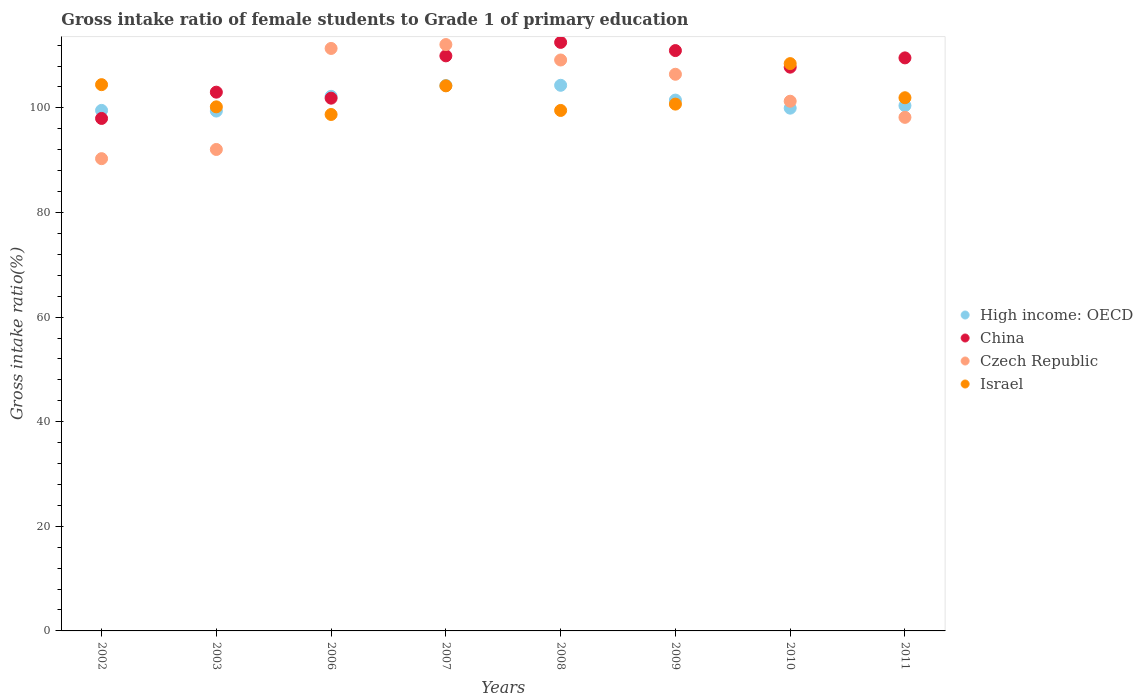Is the number of dotlines equal to the number of legend labels?
Keep it short and to the point. Yes. What is the gross intake ratio in Israel in 2003?
Your response must be concise. 100.2. Across all years, what is the maximum gross intake ratio in High income: OECD?
Your answer should be very brief. 104.32. Across all years, what is the minimum gross intake ratio in Israel?
Your answer should be compact. 98.74. In which year was the gross intake ratio in Israel maximum?
Keep it short and to the point. 2010. In which year was the gross intake ratio in China minimum?
Keep it short and to the point. 2002. What is the total gross intake ratio in China in the graph?
Your answer should be very brief. 853.61. What is the difference between the gross intake ratio in Czech Republic in 2007 and that in 2008?
Offer a terse response. 2.95. What is the difference between the gross intake ratio in High income: OECD in 2007 and the gross intake ratio in Czech Republic in 2009?
Your answer should be very brief. -2.16. What is the average gross intake ratio in High income: OECD per year?
Your answer should be compact. 101.45. In the year 2009, what is the difference between the gross intake ratio in China and gross intake ratio in High income: OECD?
Your answer should be compact. 9.47. In how many years, is the gross intake ratio in High income: OECD greater than 8 %?
Give a very brief answer. 8. What is the ratio of the gross intake ratio in Czech Republic in 2003 to that in 2007?
Your answer should be very brief. 0.82. Is the gross intake ratio in Israel in 2007 less than that in 2010?
Your response must be concise. Yes. What is the difference between the highest and the second highest gross intake ratio in China?
Your answer should be compact. 1.57. What is the difference between the highest and the lowest gross intake ratio in Israel?
Offer a very short reply. 9.73. Is the sum of the gross intake ratio in Israel in 2002 and 2006 greater than the maximum gross intake ratio in Czech Republic across all years?
Provide a succinct answer. Yes. Is it the case that in every year, the sum of the gross intake ratio in China and gross intake ratio in High income: OECD  is greater than the sum of gross intake ratio in Israel and gross intake ratio in Czech Republic?
Provide a succinct answer. No. Is the gross intake ratio in China strictly greater than the gross intake ratio in Israel over the years?
Offer a terse response. No. How many dotlines are there?
Offer a very short reply. 4. What is the difference between two consecutive major ticks on the Y-axis?
Give a very brief answer. 20. Where does the legend appear in the graph?
Give a very brief answer. Center right. What is the title of the graph?
Your response must be concise. Gross intake ratio of female students to Grade 1 of primary education. What is the label or title of the Y-axis?
Your response must be concise. Gross intake ratio(%). What is the Gross intake ratio(%) in High income: OECD in 2002?
Ensure brevity in your answer.  99.52. What is the Gross intake ratio(%) in China in 2002?
Ensure brevity in your answer.  97.98. What is the Gross intake ratio(%) in Czech Republic in 2002?
Your response must be concise. 90.29. What is the Gross intake ratio(%) of Israel in 2002?
Provide a short and direct response. 104.44. What is the Gross intake ratio(%) in High income: OECD in 2003?
Provide a short and direct response. 99.39. What is the Gross intake ratio(%) in China in 2003?
Your answer should be compact. 103. What is the Gross intake ratio(%) in Czech Republic in 2003?
Give a very brief answer. 92.05. What is the Gross intake ratio(%) of Israel in 2003?
Provide a succinct answer. 100.2. What is the Gross intake ratio(%) of High income: OECD in 2006?
Your answer should be compact. 102.21. What is the Gross intake ratio(%) in China in 2006?
Offer a terse response. 101.86. What is the Gross intake ratio(%) in Czech Republic in 2006?
Offer a terse response. 111.36. What is the Gross intake ratio(%) in Israel in 2006?
Make the answer very short. 98.74. What is the Gross intake ratio(%) in High income: OECD in 2007?
Ensure brevity in your answer.  104.27. What is the Gross intake ratio(%) of China in 2007?
Provide a short and direct response. 109.94. What is the Gross intake ratio(%) of Czech Republic in 2007?
Your answer should be very brief. 112.11. What is the Gross intake ratio(%) in Israel in 2007?
Keep it short and to the point. 104.22. What is the Gross intake ratio(%) in High income: OECD in 2008?
Provide a succinct answer. 104.32. What is the Gross intake ratio(%) in China in 2008?
Your answer should be compact. 112.52. What is the Gross intake ratio(%) of Czech Republic in 2008?
Offer a very short reply. 109.16. What is the Gross intake ratio(%) in Israel in 2008?
Your answer should be very brief. 99.51. What is the Gross intake ratio(%) of High income: OECD in 2009?
Make the answer very short. 101.49. What is the Gross intake ratio(%) of China in 2009?
Provide a succinct answer. 110.96. What is the Gross intake ratio(%) in Czech Republic in 2009?
Keep it short and to the point. 106.43. What is the Gross intake ratio(%) in Israel in 2009?
Keep it short and to the point. 100.72. What is the Gross intake ratio(%) of High income: OECD in 2010?
Provide a succinct answer. 99.95. What is the Gross intake ratio(%) of China in 2010?
Provide a succinct answer. 107.78. What is the Gross intake ratio(%) of Czech Republic in 2010?
Keep it short and to the point. 101.27. What is the Gross intake ratio(%) in Israel in 2010?
Provide a short and direct response. 108.47. What is the Gross intake ratio(%) in High income: OECD in 2011?
Ensure brevity in your answer.  100.43. What is the Gross intake ratio(%) in China in 2011?
Provide a succinct answer. 109.56. What is the Gross intake ratio(%) in Czech Republic in 2011?
Your answer should be compact. 98.19. What is the Gross intake ratio(%) of Israel in 2011?
Offer a very short reply. 101.94. Across all years, what is the maximum Gross intake ratio(%) of High income: OECD?
Keep it short and to the point. 104.32. Across all years, what is the maximum Gross intake ratio(%) in China?
Provide a short and direct response. 112.52. Across all years, what is the maximum Gross intake ratio(%) of Czech Republic?
Offer a terse response. 112.11. Across all years, what is the maximum Gross intake ratio(%) in Israel?
Provide a short and direct response. 108.47. Across all years, what is the minimum Gross intake ratio(%) of High income: OECD?
Make the answer very short. 99.39. Across all years, what is the minimum Gross intake ratio(%) of China?
Keep it short and to the point. 97.98. Across all years, what is the minimum Gross intake ratio(%) of Czech Republic?
Your response must be concise. 90.29. Across all years, what is the minimum Gross intake ratio(%) in Israel?
Your response must be concise. 98.74. What is the total Gross intake ratio(%) of High income: OECD in the graph?
Your answer should be very brief. 811.58. What is the total Gross intake ratio(%) in China in the graph?
Provide a succinct answer. 853.61. What is the total Gross intake ratio(%) in Czech Republic in the graph?
Your answer should be very brief. 820.86. What is the total Gross intake ratio(%) in Israel in the graph?
Give a very brief answer. 818.23. What is the difference between the Gross intake ratio(%) of High income: OECD in 2002 and that in 2003?
Your answer should be compact. 0.12. What is the difference between the Gross intake ratio(%) of China in 2002 and that in 2003?
Your answer should be compact. -5.02. What is the difference between the Gross intake ratio(%) in Czech Republic in 2002 and that in 2003?
Your response must be concise. -1.76. What is the difference between the Gross intake ratio(%) of Israel in 2002 and that in 2003?
Offer a very short reply. 4.24. What is the difference between the Gross intake ratio(%) of High income: OECD in 2002 and that in 2006?
Provide a succinct answer. -2.69. What is the difference between the Gross intake ratio(%) in China in 2002 and that in 2006?
Offer a very short reply. -3.88. What is the difference between the Gross intake ratio(%) of Czech Republic in 2002 and that in 2006?
Your response must be concise. -21.07. What is the difference between the Gross intake ratio(%) of Israel in 2002 and that in 2006?
Make the answer very short. 5.7. What is the difference between the Gross intake ratio(%) of High income: OECD in 2002 and that in 2007?
Give a very brief answer. -4.75. What is the difference between the Gross intake ratio(%) in China in 2002 and that in 2007?
Your response must be concise. -11.96. What is the difference between the Gross intake ratio(%) of Czech Republic in 2002 and that in 2007?
Provide a succinct answer. -21.82. What is the difference between the Gross intake ratio(%) of Israel in 2002 and that in 2007?
Offer a terse response. 0.22. What is the difference between the Gross intake ratio(%) of High income: OECD in 2002 and that in 2008?
Your answer should be compact. -4.8. What is the difference between the Gross intake ratio(%) in China in 2002 and that in 2008?
Provide a succinct answer. -14.54. What is the difference between the Gross intake ratio(%) in Czech Republic in 2002 and that in 2008?
Offer a very short reply. -18.86. What is the difference between the Gross intake ratio(%) of Israel in 2002 and that in 2008?
Keep it short and to the point. 4.93. What is the difference between the Gross intake ratio(%) in High income: OECD in 2002 and that in 2009?
Give a very brief answer. -1.97. What is the difference between the Gross intake ratio(%) of China in 2002 and that in 2009?
Ensure brevity in your answer.  -12.98. What is the difference between the Gross intake ratio(%) of Czech Republic in 2002 and that in 2009?
Provide a short and direct response. -16.14. What is the difference between the Gross intake ratio(%) in Israel in 2002 and that in 2009?
Keep it short and to the point. 3.72. What is the difference between the Gross intake ratio(%) in High income: OECD in 2002 and that in 2010?
Your response must be concise. -0.43. What is the difference between the Gross intake ratio(%) in China in 2002 and that in 2010?
Ensure brevity in your answer.  -9.8. What is the difference between the Gross intake ratio(%) of Czech Republic in 2002 and that in 2010?
Offer a terse response. -10.98. What is the difference between the Gross intake ratio(%) of Israel in 2002 and that in 2010?
Provide a short and direct response. -4.02. What is the difference between the Gross intake ratio(%) in High income: OECD in 2002 and that in 2011?
Your answer should be compact. -0.91. What is the difference between the Gross intake ratio(%) in China in 2002 and that in 2011?
Make the answer very short. -11.58. What is the difference between the Gross intake ratio(%) in Czech Republic in 2002 and that in 2011?
Ensure brevity in your answer.  -7.9. What is the difference between the Gross intake ratio(%) of Israel in 2002 and that in 2011?
Provide a succinct answer. 2.5. What is the difference between the Gross intake ratio(%) of High income: OECD in 2003 and that in 2006?
Your response must be concise. -2.81. What is the difference between the Gross intake ratio(%) of China in 2003 and that in 2006?
Provide a succinct answer. 1.15. What is the difference between the Gross intake ratio(%) of Czech Republic in 2003 and that in 2006?
Make the answer very short. -19.31. What is the difference between the Gross intake ratio(%) of Israel in 2003 and that in 2006?
Make the answer very short. 1.46. What is the difference between the Gross intake ratio(%) in High income: OECD in 2003 and that in 2007?
Ensure brevity in your answer.  -4.88. What is the difference between the Gross intake ratio(%) of China in 2003 and that in 2007?
Your answer should be very brief. -6.94. What is the difference between the Gross intake ratio(%) of Czech Republic in 2003 and that in 2007?
Provide a short and direct response. -20.06. What is the difference between the Gross intake ratio(%) in Israel in 2003 and that in 2007?
Your answer should be very brief. -4.02. What is the difference between the Gross intake ratio(%) of High income: OECD in 2003 and that in 2008?
Make the answer very short. -4.93. What is the difference between the Gross intake ratio(%) in China in 2003 and that in 2008?
Ensure brevity in your answer.  -9.52. What is the difference between the Gross intake ratio(%) in Czech Republic in 2003 and that in 2008?
Offer a terse response. -17.11. What is the difference between the Gross intake ratio(%) of Israel in 2003 and that in 2008?
Ensure brevity in your answer.  0.69. What is the difference between the Gross intake ratio(%) of High income: OECD in 2003 and that in 2009?
Offer a very short reply. -2.1. What is the difference between the Gross intake ratio(%) in China in 2003 and that in 2009?
Offer a very short reply. -7.95. What is the difference between the Gross intake ratio(%) in Czech Republic in 2003 and that in 2009?
Provide a short and direct response. -14.38. What is the difference between the Gross intake ratio(%) in Israel in 2003 and that in 2009?
Provide a short and direct response. -0.52. What is the difference between the Gross intake ratio(%) of High income: OECD in 2003 and that in 2010?
Give a very brief answer. -0.55. What is the difference between the Gross intake ratio(%) of China in 2003 and that in 2010?
Ensure brevity in your answer.  -4.78. What is the difference between the Gross intake ratio(%) in Czech Republic in 2003 and that in 2010?
Offer a terse response. -9.22. What is the difference between the Gross intake ratio(%) in Israel in 2003 and that in 2010?
Give a very brief answer. -8.27. What is the difference between the Gross intake ratio(%) in High income: OECD in 2003 and that in 2011?
Keep it short and to the point. -1.04. What is the difference between the Gross intake ratio(%) of China in 2003 and that in 2011?
Your answer should be compact. -6.55. What is the difference between the Gross intake ratio(%) in Czech Republic in 2003 and that in 2011?
Offer a very short reply. -6.14. What is the difference between the Gross intake ratio(%) in Israel in 2003 and that in 2011?
Provide a short and direct response. -1.74. What is the difference between the Gross intake ratio(%) in High income: OECD in 2006 and that in 2007?
Provide a short and direct response. -2.07. What is the difference between the Gross intake ratio(%) in China in 2006 and that in 2007?
Provide a succinct answer. -8.09. What is the difference between the Gross intake ratio(%) in Czech Republic in 2006 and that in 2007?
Offer a very short reply. -0.74. What is the difference between the Gross intake ratio(%) in Israel in 2006 and that in 2007?
Offer a very short reply. -5.48. What is the difference between the Gross intake ratio(%) of High income: OECD in 2006 and that in 2008?
Ensure brevity in your answer.  -2.11. What is the difference between the Gross intake ratio(%) of China in 2006 and that in 2008?
Offer a very short reply. -10.67. What is the difference between the Gross intake ratio(%) in Czech Republic in 2006 and that in 2008?
Provide a succinct answer. 2.21. What is the difference between the Gross intake ratio(%) of Israel in 2006 and that in 2008?
Provide a succinct answer. -0.77. What is the difference between the Gross intake ratio(%) of High income: OECD in 2006 and that in 2009?
Give a very brief answer. 0.72. What is the difference between the Gross intake ratio(%) of China in 2006 and that in 2009?
Ensure brevity in your answer.  -9.1. What is the difference between the Gross intake ratio(%) of Czech Republic in 2006 and that in 2009?
Your answer should be compact. 4.94. What is the difference between the Gross intake ratio(%) in Israel in 2006 and that in 2009?
Provide a succinct answer. -1.98. What is the difference between the Gross intake ratio(%) in High income: OECD in 2006 and that in 2010?
Your response must be concise. 2.26. What is the difference between the Gross intake ratio(%) in China in 2006 and that in 2010?
Your answer should be very brief. -5.93. What is the difference between the Gross intake ratio(%) of Czech Republic in 2006 and that in 2010?
Give a very brief answer. 10.09. What is the difference between the Gross intake ratio(%) of Israel in 2006 and that in 2010?
Provide a succinct answer. -9.73. What is the difference between the Gross intake ratio(%) in High income: OECD in 2006 and that in 2011?
Your answer should be compact. 1.78. What is the difference between the Gross intake ratio(%) of China in 2006 and that in 2011?
Offer a terse response. -7.7. What is the difference between the Gross intake ratio(%) in Czech Republic in 2006 and that in 2011?
Give a very brief answer. 13.17. What is the difference between the Gross intake ratio(%) of Israel in 2006 and that in 2011?
Make the answer very short. -3.2. What is the difference between the Gross intake ratio(%) of High income: OECD in 2007 and that in 2008?
Your answer should be compact. -0.05. What is the difference between the Gross intake ratio(%) in China in 2007 and that in 2008?
Make the answer very short. -2.58. What is the difference between the Gross intake ratio(%) of Czech Republic in 2007 and that in 2008?
Provide a succinct answer. 2.95. What is the difference between the Gross intake ratio(%) of Israel in 2007 and that in 2008?
Offer a very short reply. 4.7. What is the difference between the Gross intake ratio(%) of High income: OECD in 2007 and that in 2009?
Your answer should be compact. 2.78. What is the difference between the Gross intake ratio(%) of China in 2007 and that in 2009?
Offer a terse response. -1.01. What is the difference between the Gross intake ratio(%) of Czech Republic in 2007 and that in 2009?
Offer a very short reply. 5.68. What is the difference between the Gross intake ratio(%) in Israel in 2007 and that in 2009?
Your response must be concise. 3.49. What is the difference between the Gross intake ratio(%) in High income: OECD in 2007 and that in 2010?
Your answer should be compact. 4.32. What is the difference between the Gross intake ratio(%) in China in 2007 and that in 2010?
Provide a short and direct response. 2.16. What is the difference between the Gross intake ratio(%) in Czech Republic in 2007 and that in 2010?
Your answer should be very brief. 10.83. What is the difference between the Gross intake ratio(%) of Israel in 2007 and that in 2010?
Keep it short and to the point. -4.25. What is the difference between the Gross intake ratio(%) in High income: OECD in 2007 and that in 2011?
Your answer should be very brief. 3.84. What is the difference between the Gross intake ratio(%) in China in 2007 and that in 2011?
Offer a terse response. 0.39. What is the difference between the Gross intake ratio(%) in Czech Republic in 2007 and that in 2011?
Make the answer very short. 13.92. What is the difference between the Gross intake ratio(%) of Israel in 2007 and that in 2011?
Keep it short and to the point. 2.28. What is the difference between the Gross intake ratio(%) of High income: OECD in 2008 and that in 2009?
Give a very brief answer. 2.83. What is the difference between the Gross intake ratio(%) of China in 2008 and that in 2009?
Offer a very short reply. 1.57. What is the difference between the Gross intake ratio(%) of Czech Republic in 2008 and that in 2009?
Offer a terse response. 2.73. What is the difference between the Gross intake ratio(%) in Israel in 2008 and that in 2009?
Provide a short and direct response. -1.21. What is the difference between the Gross intake ratio(%) of High income: OECD in 2008 and that in 2010?
Ensure brevity in your answer.  4.37. What is the difference between the Gross intake ratio(%) in China in 2008 and that in 2010?
Give a very brief answer. 4.74. What is the difference between the Gross intake ratio(%) of Czech Republic in 2008 and that in 2010?
Your response must be concise. 7.88. What is the difference between the Gross intake ratio(%) in Israel in 2008 and that in 2010?
Provide a succinct answer. -8.95. What is the difference between the Gross intake ratio(%) of High income: OECD in 2008 and that in 2011?
Give a very brief answer. 3.89. What is the difference between the Gross intake ratio(%) of China in 2008 and that in 2011?
Offer a terse response. 2.96. What is the difference between the Gross intake ratio(%) of Czech Republic in 2008 and that in 2011?
Your answer should be very brief. 10.97. What is the difference between the Gross intake ratio(%) in Israel in 2008 and that in 2011?
Your response must be concise. -2.43. What is the difference between the Gross intake ratio(%) in High income: OECD in 2009 and that in 2010?
Your answer should be very brief. 1.54. What is the difference between the Gross intake ratio(%) in China in 2009 and that in 2010?
Keep it short and to the point. 3.17. What is the difference between the Gross intake ratio(%) of Czech Republic in 2009 and that in 2010?
Your answer should be compact. 5.15. What is the difference between the Gross intake ratio(%) of Israel in 2009 and that in 2010?
Ensure brevity in your answer.  -7.74. What is the difference between the Gross intake ratio(%) in High income: OECD in 2009 and that in 2011?
Your response must be concise. 1.06. What is the difference between the Gross intake ratio(%) in China in 2009 and that in 2011?
Your response must be concise. 1.4. What is the difference between the Gross intake ratio(%) in Czech Republic in 2009 and that in 2011?
Offer a very short reply. 8.24. What is the difference between the Gross intake ratio(%) in Israel in 2009 and that in 2011?
Make the answer very short. -1.22. What is the difference between the Gross intake ratio(%) in High income: OECD in 2010 and that in 2011?
Your answer should be compact. -0.48. What is the difference between the Gross intake ratio(%) of China in 2010 and that in 2011?
Ensure brevity in your answer.  -1.77. What is the difference between the Gross intake ratio(%) of Czech Republic in 2010 and that in 2011?
Give a very brief answer. 3.08. What is the difference between the Gross intake ratio(%) in Israel in 2010 and that in 2011?
Provide a succinct answer. 6.53. What is the difference between the Gross intake ratio(%) in High income: OECD in 2002 and the Gross intake ratio(%) in China in 2003?
Give a very brief answer. -3.49. What is the difference between the Gross intake ratio(%) of High income: OECD in 2002 and the Gross intake ratio(%) of Czech Republic in 2003?
Ensure brevity in your answer.  7.47. What is the difference between the Gross intake ratio(%) in High income: OECD in 2002 and the Gross intake ratio(%) in Israel in 2003?
Offer a very short reply. -0.68. What is the difference between the Gross intake ratio(%) in China in 2002 and the Gross intake ratio(%) in Czech Republic in 2003?
Keep it short and to the point. 5.93. What is the difference between the Gross intake ratio(%) in China in 2002 and the Gross intake ratio(%) in Israel in 2003?
Give a very brief answer. -2.22. What is the difference between the Gross intake ratio(%) in Czech Republic in 2002 and the Gross intake ratio(%) in Israel in 2003?
Offer a terse response. -9.91. What is the difference between the Gross intake ratio(%) in High income: OECD in 2002 and the Gross intake ratio(%) in China in 2006?
Provide a short and direct response. -2.34. What is the difference between the Gross intake ratio(%) in High income: OECD in 2002 and the Gross intake ratio(%) in Czech Republic in 2006?
Give a very brief answer. -11.85. What is the difference between the Gross intake ratio(%) in High income: OECD in 2002 and the Gross intake ratio(%) in Israel in 2006?
Make the answer very short. 0.78. What is the difference between the Gross intake ratio(%) of China in 2002 and the Gross intake ratio(%) of Czech Republic in 2006?
Provide a short and direct response. -13.38. What is the difference between the Gross intake ratio(%) of China in 2002 and the Gross intake ratio(%) of Israel in 2006?
Offer a very short reply. -0.76. What is the difference between the Gross intake ratio(%) of Czech Republic in 2002 and the Gross intake ratio(%) of Israel in 2006?
Provide a succinct answer. -8.45. What is the difference between the Gross intake ratio(%) of High income: OECD in 2002 and the Gross intake ratio(%) of China in 2007?
Make the answer very short. -10.43. What is the difference between the Gross intake ratio(%) in High income: OECD in 2002 and the Gross intake ratio(%) in Czech Republic in 2007?
Keep it short and to the point. -12.59. What is the difference between the Gross intake ratio(%) in High income: OECD in 2002 and the Gross intake ratio(%) in Israel in 2007?
Your answer should be compact. -4.7. What is the difference between the Gross intake ratio(%) in China in 2002 and the Gross intake ratio(%) in Czech Republic in 2007?
Give a very brief answer. -14.13. What is the difference between the Gross intake ratio(%) in China in 2002 and the Gross intake ratio(%) in Israel in 2007?
Ensure brevity in your answer.  -6.24. What is the difference between the Gross intake ratio(%) of Czech Republic in 2002 and the Gross intake ratio(%) of Israel in 2007?
Keep it short and to the point. -13.92. What is the difference between the Gross intake ratio(%) in High income: OECD in 2002 and the Gross intake ratio(%) in China in 2008?
Offer a very short reply. -13. What is the difference between the Gross intake ratio(%) in High income: OECD in 2002 and the Gross intake ratio(%) in Czech Republic in 2008?
Your answer should be very brief. -9.64. What is the difference between the Gross intake ratio(%) of High income: OECD in 2002 and the Gross intake ratio(%) of Israel in 2008?
Offer a very short reply. 0.01. What is the difference between the Gross intake ratio(%) in China in 2002 and the Gross intake ratio(%) in Czech Republic in 2008?
Ensure brevity in your answer.  -11.18. What is the difference between the Gross intake ratio(%) in China in 2002 and the Gross intake ratio(%) in Israel in 2008?
Your answer should be very brief. -1.53. What is the difference between the Gross intake ratio(%) of Czech Republic in 2002 and the Gross intake ratio(%) of Israel in 2008?
Offer a terse response. -9.22. What is the difference between the Gross intake ratio(%) in High income: OECD in 2002 and the Gross intake ratio(%) in China in 2009?
Your response must be concise. -11.44. What is the difference between the Gross intake ratio(%) of High income: OECD in 2002 and the Gross intake ratio(%) of Czech Republic in 2009?
Offer a very short reply. -6.91. What is the difference between the Gross intake ratio(%) in High income: OECD in 2002 and the Gross intake ratio(%) in Israel in 2009?
Give a very brief answer. -1.2. What is the difference between the Gross intake ratio(%) in China in 2002 and the Gross intake ratio(%) in Czech Republic in 2009?
Your response must be concise. -8.45. What is the difference between the Gross intake ratio(%) of China in 2002 and the Gross intake ratio(%) of Israel in 2009?
Your answer should be compact. -2.74. What is the difference between the Gross intake ratio(%) of Czech Republic in 2002 and the Gross intake ratio(%) of Israel in 2009?
Provide a short and direct response. -10.43. What is the difference between the Gross intake ratio(%) in High income: OECD in 2002 and the Gross intake ratio(%) in China in 2010?
Your response must be concise. -8.27. What is the difference between the Gross intake ratio(%) in High income: OECD in 2002 and the Gross intake ratio(%) in Czech Republic in 2010?
Provide a succinct answer. -1.75. What is the difference between the Gross intake ratio(%) of High income: OECD in 2002 and the Gross intake ratio(%) of Israel in 2010?
Your response must be concise. -8.95. What is the difference between the Gross intake ratio(%) in China in 2002 and the Gross intake ratio(%) in Czech Republic in 2010?
Offer a very short reply. -3.29. What is the difference between the Gross intake ratio(%) of China in 2002 and the Gross intake ratio(%) of Israel in 2010?
Keep it short and to the point. -10.48. What is the difference between the Gross intake ratio(%) of Czech Republic in 2002 and the Gross intake ratio(%) of Israel in 2010?
Your response must be concise. -18.17. What is the difference between the Gross intake ratio(%) in High income: OECD in 2002 and the Gross intake ratio(%) in China in 2011?
Offer a very short reply. -10.04. What is the difference between the Gross intake ratio(%) of High income: OECD in 2002 and the Gross intake ratio(%) of Czech Republic in 2011?
Provide a short and direct response. 1.33. What is the difference between the Gross intake ratio(%) in High income: OECD in 2002 and the Gross intake ratio(%) in Israel in 2011?
Your response must be concise. -2.42. What is the difference between the Gross intake ratio(%) in China in 2002 and the Gross intake ratio(%) in Czech Republic in 2011?
Provide a succinct answer. -0.21. What is the difference between the Gross intake ratio(%) of China in 2002 and the Gross intake ratio(%) of Israel in 2011?
Your answer should be compact. -3.96. What is the difference between the Gross intake ratio(%) of Czech Republic in 2002 and the Gross intake ratio(%) of Israel in 2011?
Your response must be concise. -11.65. What is the difference between the Gross intake ratio(%) in High income: OECD in 2003 and the Gross intake ratio(%) in China in 2006?
Provide a succinct answer. -2.46. What is the difference between the Gross intake ratio(%) of High income: OECD in 2003 and the Gross intake ratio(%) of Czech Republic in 2006?
Ensure brevity in your answer.  -11.97. What is the difference between the Gross intake ratio(%) in High income: OECD in 2003 and the Gross intake ratio(%) in Israel in 2006?
Provide a short and direct response. 0.66. What is the difference between the Gross intake ratio(%) in China in 2003 and the Gross intake ratio(%) in Czech Republic in 2006?
Your answer should be compact. -8.36. What is the difference between the Gross intake ratio(%) of China in 2003 and the Gross intake ratio(%) of Israel in 2006?
Your response must be concise. 4.27. What is the difference between the Gross intake ratio(%) of Czech Republic in 2003 and the Gross intake ratio(%) of Israel in 2006?
Provide a succinct answer. -6.69. What is the difference between the Gross intake ratio(%) of High income: OECD in 2003 and the Gross intake ratio(%) of China in 2007?
Offer a terse response. -10.55. What is the difference between the Gross intake ratio(%) of High income: OECD in 2003 and the Gross intake ratio(%) of Czech Republic in 2007?
Provide a short and direct response. -12.71. What is the difference between the Gross intake ratio(%) in High income: OECD in 2003 and the Gross intake ratio(%) in Israel in 2007?
Offer a very short reply. -4.82. What is the difference between the Gross intake ratio(%) in China in 2003 and the Gross intake ratio(%) in Czech Republic in 2007?
Make the answer very short. -9.1. What is the difference between the Gross intake ratio(%) in China in 2003 and the Gross intake ratio(%) in Israel in 2007?
Give a very brief answer. -1.21. What is the difference between the Gross intake ratio(%) in Czech Republic in 2003 and the Gross intake ratio(%) in Israel in 2007?
Provide a short and direct response. -12.17. What is the difference between the Gross intake ratio(%) of High income: OECD in 2003 and the Gross intake ratio(%) of China in 2008?
Keep it short and to the point. -13.13. What is the difference between the Gross intake ratio(%) of High income: OECD in 2003 and the Gross intake ratio(%) of Czech Republic in 2008?
Give a very brief answer. -9.76. What is the difference between the Gross intake ratio(%) in High income: OECD in 2003 and the Gross intake ratio(%) in Israel in 2008?
Provide a succinct answer. -0.12. What is the difference between the Gross intake ratio(%) of China in 2003 and the Gross intake ratio(%) of Czech Republic in 2008?
Make the answer very short. -6.15. What is the difference between the Gross intake ratio(%) of China in 2003 and the Gross intake ratio(%) of Israel in 2008?
Provide a succinct answer. 3.49. What is the difference between the Gross intake ratio(%) of Czech Republic in 2003 and the Gross intake ratio(%) of Israel in 2008?
Keep it short and to the point. -7.46. What is the difference between the Gross intake ratio(%) in High income: OECD in 2003 and the Gross intake ratio(%) in China in 2009?
Offer a terse response. -11.56. What is the difference between the Gross intake ratio(%) of High income: OECD in 2003 and the Gross intake ratio(%) of Czech Republic in 2009?
Your response must be concise. -7.03. What is the difference between the Gross intake ratio(%) in High income: OECD in 2003 and the Gross intake ratio(%) in Israel in 2009?
Provide a short and direct response. -1.33. What is the difference between the Gross intake ratio(%) in China in 2003 and the Gross intake ratio(%) in Czech Republic in 2009?
Your answer should be compact. -3.42. What is the difference between the Gross intake ratio(%) in China in 2003 and the Gross intake ratio(%) in Israel in 2009?
Offer a terse response. 2.28. What is the difference between the Gross intake ratio(%) in Czech Republic in 2003 and the Gross intake ratio(%) in Israel in 2009?
Offer a terse response. -8.67. What is the difference between the Gross intake ratio(%) of High income: OECD in 2003 and the Gross intake ratio(%) of China in 2010?
Your answer should be very brief. -8.39. What is the difference between the Gross intake ratio(%) of High income: OECD in 2003 and the Gross intake ratio(%) of Czech Republic in 2010?
Make the answer very short. -1.88. What is the difference between the Gross intake ratio(%) in High income: OECD in 2003 and the Gross intake ratio(%) in Israel in 2010?
Offer a terse response. -9.07. What is the difference between the Gross intake ratio(%) of China in 2003 and the Gross intake ratio(%) of Czech Republic in 2010?
Keep it short and to the point. 1.73. What is the difference between the Gross intake ratio(%) in China in 2003 and the Gross intake ratio(%) in Israel in 2010?
Offer a terse response. -5.46. What is the difference between the Gross intake ratio(%) of Czech Republic in 2003 and the Gross intake ratio(%) of Israel in 2010?
Provide a short and direct response. -16.42. What is the difference between the Gross intake ratio(%) in High income: OECD in 2003 and the Gross intake ratio(%) in China in 2011?
Give a very brief answer. -10.16. What is the difference between the Gross intake ratio(%) of High income: OECD in 2003 and the Gross intake ratio(%) of Czech Republic in 2011?
Your answer should be compact. 1.2. What is the difference between the Gross intake ratio(%) of High income: OECD in 2003 and the Gross intake ratio(%) of Israel in 2011?
Keep it short and to the point. -2.54. What is the difference between the Gross intake ratio(%) of China in 2003 and the Gross intake ratio(%) of Czech Republic in 2011?
Offer a terse response. 4.81. What is the difference between the Gross intake ratio(%) of China in 2003 and the Gross intake ratio(%) of Israel in 2011?
Your response must be concise. 1.07. What is the difference between the Gross intake ratio(%) of Czech Republic in 2003 and the Gross intake ratio(%) of Israel in 2011?
Provide a short and direct response. -9.89. What is the difference between the Gross intake ratio(%) in High income: OECD in 2006 and the Gross intake ratio(%) in China in 2007?
Make the answer very short. -7.74. What is the difference between the Gross intake ratio(%) of High income: OECD in 2006 and the Gross intake ratio(%) of Czech Republic in 2007?
Provide a succinct answer. -9.9. What is the difference between the Gross intake ratio(%) of High income: OECD in 2006 and the Gross intake ratio(%) of Israel in 2007?
Make the answer very short. -2.01. What is the difference between the Gross intake ratio(%) in China in 2006 and the Gross intake ratio(%) in Czech Republic in 2007?
Give a very brief answer. -10.25. What is the difference between the Gross intake ratio(%) of China in 2006 and the Gross intake ratio(%) of Israel in 2007?
Make the answer very short. -2.36. What is the difference between the Gross intake ratio(%) in Czech Republic in 2006 and the Gross intake ratio(%) in Israel in 2007?
Offer a terse response. 7.15. What is the difference between the Gross intake ratio(%) in High income: OECD in 2006 and the Gross intake ratio(%) in China in 2008?
Offer a very short reply. -10.32. What is the difference between the Gross intake ratio(%) in High income: OECD in 2006 and the Gross intake ratio(%) in Czech Republic in 2008?
Offer a terse response. -6.95. What is the difference between the Gross intake ratio(%) in High income: OECD in 2006 and the Gross intake ratio(%) in Israel in 2008?
Offer a terse response. 2.7. What is the difference between the Gross intake ratio(%) in China in 2006 and the Gross intake ratio(%) in Czech Republic in 2008?
Offer a terse response. -7.3. What is the difference between the Gross intake ratio(%) in China in 2006 and the Gross intake ratio(%) in Israel in 2008?
Your answer should be very brief. 2.35. What is the difference between the Gross intake ratio(%) in Czech Republic in 2006 and the Gross intake ratio(%) in Israel in 2008?
Keep it short and to the point. 11.85. What is the difference between the Gross intake ratio(%) of High income: OECD in 2006 and the Gross intake ratio(%) of China in 2009?
Keep it short and to the point. -8.75. What is the difference between the Gross intake ratio(%) in High income: OECD in 2006 and the Gross intake ratio(%) in Czech Republic in 2009?
Give a very brief answer. -4.22. What is the difference between the Gross intake ratio(%) of High income: OECD in 2006 and the Gross intake ratio(%) of Israel in 2009?
Give a very brief answer. 1.49. What is the difference between the Gross intake ratio(%) of China in 2006 and the Gross intake ratio(%) of Czech Republic in 2009?
Give a very brief answer. -4.57. What is the difference between the Gross intake ratio(%) in China in 2006 and the Gross intake ratio(%) in Israel in 2009?
Give a very brief answer. 1.13. What is the difference between the Gross intake ratio(%) in Czech Republic in 2006 and the Gross intake ratio(%) in Israel in 2009?
Offer a very short reply. 10.64. What is the difference between the Gross intake ratio(%) of High income: OECD in 2006 and the Gross intake ratio(%) of China in 2010?
Ensure brevity in your answer.  -5.58. What is the difference between the Gross intake ratio(%) in High income: OECD in 2006 and the Gross intake ratio(%) in Czech Republic in 2010?
Offer a terse response. 0.93. What is the difference between the Gross intake ratio(%) in High income: OECD in 2006 and the Gross intake ratio(%) in Israel in 2010?
Provide a succinct answer. -6.26. What is the difference between the Gross intake ratio(%) of China in 2006 and the Gross intake ratio(%) of Czech Republic in 2010?
Offer a terse response. 0.58. What is the difference between the Gross intake ratio(%) of China in 2006 and the Gross intake ratio(%) of Israel in 2010?
Give a very brief answer. -6.61. What is the difference between the Gross intake ratio(%) in Czech Republic in 2006 and the Gross intake ratio(%) in Israel in 2010?
Ensure brevity in your answer.  2.9. What is the difference between the Gross intake ratio(%) in High income: OECD in 2006 and the Gross intake ratio(%) in China in 2011?
Your answer should be compact. -7.35. What is the difference between the Gross intake ratio(%) of High income: OECD in 2006 and the Gross intake ratio(%) of Czech Republic in 2011?
Ensure brevity in your answer.  4.02. What is the difference between the Gross intake ratio(%) of High income: OECD in 2006 and the Gross intake ratio(%) of Israel in 2011?
Give a very brief answer. 0.27. What is the difference between the Gross intake ratio(%) of China in 2006 and the Gross intake ratio(%) of Czech Republic in 2011?
Make the answer very short. 3.67. What is the difference between the Gross intake ratio(%) in China in 2006 and the Gross intake ratio(%) in Israel in 2011?
Your answer should be compact. -0.08. What is the difference between the Gross intake ratio(%) of Czech Republic in 2006 and the Gross intake ratio(%) of Israel in 2011?
Keep it short and to the point. 9.43. What is the difference between the Gross intake ratio(%) of High income: OECD in 2007 and the Gross intake ratio(%) of China in 2008?
Your response must be concise. -8.25. What is the difference between the Gross intake ratio(%) in High income: OECD in 2007 and the Gross intake ratio(%) in Czech Republic in 2008?
Keep it short and to the point. -4.88. What is the difference between the Gross intake ratio(%) in High income: OECD in 2007 and the Gross intake ratio(%) in Israel in 2008?
Your response must be concise. 4.76. What is the difference between the Gross intake ratio(%) in China in 2007 and the Gross intake ratio(%) in Czech Republic in 2008?
Your response must be concise. 0.79. What is the difference between the Gross intake ratio(%) in China in 2007 and the Gross intake ratio(%) in Israel in 2008?
Offer a very short reply. 10.43. What is the difference between the Gross intake ratio(%) in Czech Republic in 2007 and the Gross intake ratio(%) in Israel in 2008?
Ensure brevity in your answer.  12.6. What is the difference between the Gross intake ratio(%) of High income: OECD in 2007 and the Gross intake ratio(%) of China in 2009?
Provide a succinct answer. -6.68. What is the difference between the Gross intake ratio(%) of High income: OECD in 2007 and the Gross intake ratio(%) of Czech Republic in 2009?
Your answer should be compact. -2.16. What is the difference between the Gross intake ratio(%) of High income: OECD in 2007 and the Gross intake ratio(%) of Israel in 2009?
Ensure brevity in your answer.  3.55. What is the difference between the Gross intake ratio(%) in China in 2007 and the Gross intake ratio(%) in Czech Republic in 2009?
Ensure brevity in your answer.  3.52. What is the difference between the Gross intake ratio(%) in China in 2007 and the Gross intake ratio(%) in Israel in 2009?
Make the answer very short. 9.22. What is the difference between the Gross intake ratio(%) in Czech Republic in 2007 and the Gross intake ratio(%) in Israel in 2009?
Provide a short and direct response. 11.38. What is the difference between the Gross intake ratio(%) of High income: OECD in 2007 and the Gross intake ratio(%) of China in 2010?
Your answer should be compact. -3.51. What is the difference between the Gross intake ratio(%) of High income: OECD in 2007 and the Gross intake ratio(%) of Czech Republic in 2010?
Offer a very short reply. 3. What is the difference between the Gross intake ratio(%) in High income: OECD in 2007 and the Gross intake ratio(%) in Israel in 2010?
Ensure brevity in your answer.  -4.19. What is the difference between the Gross intake ratio(%) of China in 2007 and the Gross intake ratio(%) of Czech Republic in 2010?
Offer a terse response. 8.67. What is the difference between the Gross intake ratio(%) of China in 2007 and the Gross intake ratio(%) of Israel in 2010?
Give a very brief answer. 1.48. What is the difference between the Gross intake ratio(%) of Czech Republic in 2007 and the Gross intake ratio(%) of Israel in 2010?
Keep it short and to the point. 3.64. What is the difference between the Gross intake ratio(%) of High income: OECD in 2007 and the Gross intake ratio(%) of China in 2011?
Your answer should be compact. -5.29. What is the difference between the Gross intake ratio(%) of High income: OECD in 2007 and the Gross intake ratio(%) of Czech Republic in 2011?
Keep it short and to the point. 6.08. What is the difference between the Gross intake ratio(%) of High income: OECD in 2007 and the Gross intake ratio(%) of Israel in 2011?
Offer a very short reply. 2.33. What is the difference between the Gross intake ratio(%) of China in 2007 and the Gross intake ratio(%) of Czech Republic in 2011?
Offer a terse response. 11.75. What is the difference between the Gross intake ratio(%) in China in 2007 and the Gross intake ratio(%) in Israel in 2011?
Keep it short and to the point. 8.01. What is the difference between the Gross intake ratio(%) in Czech Republic in 2007 and the Gross intake ratio(%) in Israel in 2011?
Give a very brief answer. 10.17. What is the difference between the Gross intake ratio(%) in High income: OECD in 2008 and the Gross intake ratio(%) in China in 2009?
Your answer should be compact. -6.64. What is the difference between the Gross intake ratio(%) of High income: OECD in 2008 and the Gross intake ratio(%) of Czech Republic in 2009?
Ensure brevity in your answer.  -2.11. What is the difference between the Gross intake ratio(%) of High income: OECD in 2008 and the Gross intake ratio(%) of Israel in 2009?
Your response must be concise. 3.6. What is the difference between the Gross intake ratio(%) of China in 2008 and the Gross intake ratio(%) of Czech Republic in 2009?
Your answer should be very brief. 6.09. What is the difference between the Gross intake ratio(%) in China in 2008 and the Gross intake ratio(%) in Israel in 2009?
Give a very brief answer. 11.8. What is the difference between the Gross intake ratio(%) in Czech Republic in 2008 and the Gross intake ratio(%) in Israel in 2009?
Provide a short and direct response. 8.43. What is the difference between the Gross intake ratio(%) in High income: OECD in 2008 and the Gross intake ratio(%) in China in 2010?
Provide a succinct answer. -3.46. What is the difference between the Gross intake ratio(%) of High income: OECD in 2008 and the Gross intake ratio(%) of Czech Republic in 2010?
Offer a terse response. 3.05. What is the difference between the Gross intake ratio(%) of High income: OECD in 2008 and the Gross intake ratio(%) of Israel in 2010?
Provide a short and direct response. -4.15. What is the difference between the Gross intake ratio(%) of China in 2008 and the Gross intake ratio(%) of Czech Republic in 2010?
Ensure brevity in your answer.  11.25. What is the difference between the Gross intake ratio(%) of China in 2008 and the Gross intake ratio(%) of Israel in 2010?
Offer a terse response. 4.06. What is the difference between the Gross intake ratio(%) in Czech Republic in 2008 and the Gross intake ratio(%) in Israel in 2010?
Keep it short and to the point. 0.69. What is the difference between the Gross intake ratio(%) in High income: OECD in 2008 and the Gross intake ratio(%) in China in 2011?
Provide a succinct answer. -5.24. What is the difference between the Gross intake ratio(%) in High income: OECD in 2008 and the Gross intake ratio(%) in Czech Republic in 2011?
Keep it short and to the point. 6.13. What is the difference between the Gross intake ratio(%) in High income: OECD in 2008 and the Gross intake ratio(%) in Israel in 2011?
Give a very brief answer. 2.38. What is the difference between the Gross intake ratio(%) in China in 2008 and the Gross intake ratio(%) in Czech Republic in 2011?
Ensure brevity in your answer.  14.33. What is the difference between the Gross intake ratio(%) in China in 2008 and the Gross intake ratio(%) in Israel in 2011?
Give a very brief answer. 10.58. What is the difference between the Gross intake ratio(%) in Czech Republic in 2008 and the Gross intake ratio(%) in Israel in 2011?
Your response must be concise. 7.22. What is the difference between the Gross intake ratio(%) of High income: OECD in 2009 and the Gross intake ratio(%) of China in 2010?
Provide a short and direct response. -6.29. What is the difference between the Gross intake ratio(%) in High income: OECD in 2009 and the Gross intake ratio(%) in Czech Republic in 2010?
Your answer should be very brief. 0.22. What is the difference between the Gross intake ratio(%) in High income: OECD in 2009 and the Gross intake ratio(%) in Israel in 2010?
Your answer should be compact. -6.97. What is the difference between the Gross intake ratio(%) of China in 2009 and the Gross intake ratio(%) of Czech Republic in 2010?
Provide a short and direct response. 9.68. What is the difference between the Gross intake ratio(%) of China in 2009 and the Gross intake ratio(%) of Israel in 2010?
Ensure brevity in your answer.  2.49. What is the difference between the Gross intake ratio(%) in Czech Republic in 2009 and the Gross intake ratio(%) in Israel in 2010?
Your response must be concise. -2.04. What is the difference between the Gross intake ratio(%) of High income: OECD in 2009 and the Gross intake ratio(%) of China in 2011?
Your response must be concise. -8.07. What is the difference between the Gross intake ratio(%) of High income: OECD in 2009 and the Gross intake ratio(%) of Czech Republic in 2011?
Your response must be concise. 3.3. What is the difference between the Gross intake ratio(%) in High income: OECD in 2009 and the Gross intake ratio(%) in Israel in 2011?
Your response must be concise. -0.45. What is the difference between the Gross intake ratio(%) of China in 2009 and the Gross intake ratio(%) of Czech Republic in 2011?
Give a very brief answer. 12.77. What is the difference between the Gross intake ratio(%) in China in 2009 and the Gross intake ratio(%) in Israel in 2011?
Make the answer very short. 9.02. What is the difference between the Gross intake ratio(%) in Czech Republic in 2009 and the Gross intake ratio(%) in Israel in 2011?
Make the answer very short. 4.49. What is the difference between the Gross intake ratio(%) in High income: OECD in 2010 and the Gross intake ratio(%) in China in 2011?
Make the answer very short. -9.61. What is the difference between the Gross intake ratio(%) of High income: OECD in 2010 and the Gross intake ratio(%) of Czech Republic in 2011?
Your answer should be very brief. 1.76. What is the difference between the Gross intake ratio(%) of High income: OECD in 2010 and the Gross intake ratio(%) of Israel in 2011?
Keep it short and to the point. -1.99. What is the difference between the Gross intake ratio(%) of China in 2010 and the Gross intake ratio(%) of Czech Republic in 2011?
Offer a terse response. 9.59. What is the difference between the Gross intake ratio(%) in China in 2010 and the Gross intake ratio(%) in Israel in 2011?
Give a very brief answer. 5.85. What is the difference between the Gross intake ratio(%) in Czech Republic in 2010 and the Gross intake ratio(%) in Israel in 2011?
Your answer should be very brief. -0.67. What is the average Gross intake ratio(%) of High income: OECD per year?
Provide a succinct answer. 101.45. What is the average Gross intake ratio(%) of China per year?
Your answer should be very brief. 106.7. What is the average Gross intake ratio(%) of Czech Republic per year?
Offer a terse response. 102.61. What is the average Gross intake ratio(%) of Israel per year?
Keep it short and to the point. 102.28. In the year 2002, what is the difference between the Gross intake ratio(%) in High income: OECD and Gross intake ratio(%) in China?
Keep it short and to the point. 1.54. In the year 2002, what is the difference between the Gross intake ratio(%) of High income: OECD and Gross intake ratio(%) of Czech Republic?
Give a very brief answer. 9.23. In the year 2002, what is the difference between the Gross intake ratio(%) of High income: OECD and Gross intake ratio(%) of Israel?
Your answer should be very brief. -4.92. In the year 2002, what is the difference between the Gross intake ratio(%) of China and Gross intake ratio(%) of Czech Republic?
Offer a terse response. 7.69. In the year 2002, what is the difference between the Gross intake ratio(%) of China and Gross intake ratio(%) of Israel?
Provide a short and direct response. -6.46. In the year 2002, what is the difference between the Gross intake ratio(%) in Czech Republic and Gross intake ratio(%) in Israel?
Ensure brevity in your answer.  -14.15. In the year 2003, what is the difference between the Gross intake ratio(%) in High income: OECD and Gross intake ratio(%) in China?
Keep it short and to the point. -3.61. In the year 2003, what is the difference between the Gross intake ratio(%) of High income: OECD and Gross intake ratio(%) of Czech Republic?
Provide a short and direct response. 7.34. In the year 2003, what is the difference between the Gross intake ratio(%) of High income: OECD and Gross intake ratio(%) of Israel?
Provide a succinct answer. -0.8. In the year 2003, what is the difference between the Gross intake ratio(%) in China and Gross intake ratio(%) in Czech Republic?
Ensure brevity in your answer.  10.96. In the year 2003, what is the difference between the Gross intake ratio(%) in China and Gross intake ratio(%) in Israel?
Provide a succinct answer. 2.81. In the year 2003, what is the difference between the Gross intake ratio(%) in Czech Republic and Gross intake ratio(%) in Israel?
Make the answer very short. -8.15. In the year 2006, what is the difference between the Gross intake ratio(%) in High income: OECD and Gross intake ratio(%) in China?
Provide a short and direct response. 0.35. In the year 2006, what is the difference between the Gross intake ratio(%) of High income: OECD and Gross intake ratio(%) of Czech Republic?
Offer a terse response. -9.16. In the year 2006, what is the difference between the Gross intake ratio(%) of High income: OECD and Gross intake ratio(%) of Israel?
Provide a short and direct response. 3.47. In the year 2006, what is the difference between the Gross intake ratio(%) in China and Gross intake ratio(%) in Czech Republic?
Your response must be concise. -9.51. In the year 2006, what is the difference between the Gross intake ratio(%) in China and Gross intake ratio(%) in Israel?
Keep it short and to the point. 3.12. In the year 2006, what is the difference between the Gross intake ratio(%) of Czech Republic and Gross intake ratio(%) of Israel?
Ensure brevity in your answer.  12.63. In the year 2007, what is the difference between the Gross intake ratio(%) of High income: OECD and Gross intake ratio(%) of China?
Offer a very short reply. -5.67. In the year 2007, what is the difference between the Gross intake ratio(%) in High income: OECD and Gross intake ratio(%) in Czech Republic?
Ensure brevity in your answer.  -7.83. In the year 2007, what is the difference between the Gross intake ratio(%) in High income: OECD and Gross intake ratio(%) in Israel?
Your response must be concise. 0.06. In the year 2007, what is the difference between the Gross intake ratio(%) of China and Gross intake ratio(%) of Czech Republic?
Provide a succinct answer. -2.16. In the year 2007, what is the difference between the Gross intake ratio(%) of China and Gross intake ratio(%) of Israel?
Ensure brevity in your answer.  5.73. In the year 2007, what is the difference between the Gross intake ratio(%) of Czech Republic and Gross intake ratio(%) of Israel?
Keep it short and to the point. 7.89. In the year 2008, what is the difference between the Gross intake ratio(%) in High income: OECD and Gross intake ratio(%) in China?
Offer a very short reply. -8.2. In the year 2008, what is the difference between the Gross intake ratio(%) in High income: OECD and Gross intake ratio(%) in Czech Republic?
Offer a terse response. -4.84. In the year 2008, what is the difference between the Gross intake ratio(%) in High income: OECD and Gross intake ratio(%) in Israel?
Ensure brevity in your answer.  4.81. In the year 2008, what is the difference between the Gross intake ratio(%) in China and Gross intake ratio(%) in Czech Republic?
Keep it short and to the point. 3.37. In the year 2008, what is the difference between the Gross intake ratio(%) of China and Gross intake ratio(%) of Israel?
Ensure brevity in your answer.  13.01. In the year 2008, what is the difference between the Gross intake ratio(%) in Czech Republic and Gross intake ratio(%) in Israel?
Provide a short and direct response. 9.65. In the year 2009, what is the difference between the Gross intake ratio(%) of High income: OECD and Gross intake ratio(%) of China?
Make the answer very short. -9.47. In the year 2009, what is the difference between the Gross intake ratio(%) of High income: OECD and Gross intake ratio(%) of Czech Republic?
Provide a short and direct response. -4.94. In the year 2009, what is the difference between the Gross intake ratio(%) in High income: OECD and Gross intake ratio(%) in Israel?
Keep it short and to the point. 0.77. In the year 2009, what is the difference between the Gross intake ratio(%) of China and Gross intake ratio(%) of Czech Republic?
Provide a short and direct response. 4.53. In the year 2009, what is the difference between the Gross intake ratio(%) in China and Gross intake ratio(%) in Israel?
Your answer should be compact. 10.24. In the year 2009, what is the difference between the Gross intake ratio(%) in Czech Republic and Gross intake ratio(%) in Israel?
Offer a terse response. 5.71. In the year 2010, what is the difference between the Gross intake ratio(%) in High income: OECD and Gross intake ratio(%) in China?
Keep it short and to the point. -7.84. In the year 2010, what is the difference between the Gross intake ratio(%) of High income: OECD and Gross intake ratio(%) of Czech Republic?
Your response must be concise. -1.33. In the year 2010, what is the difference between the Gross intake ratio(%) in High income: OECD and Gross intake ratio(%) in Israel?
Keep it short and to the point. -8.52. In the year 2010, what is the difference between the Gross intake ratio(%) of China and Gross intake ratio(%) of Czech Republic?
Keep it short and to the point. 6.51. In the year 2010, what is the difference between the Gross intake ratio(%) in China and Gross intake ratio(%) in Israel?
Your answer should be very brief. -0.68. In the year 2010, what is the difference between the Gross intake ratio(%) of Czech Republic and Gross intake ratio(%) of Israel?
Provide a short and direct response. -7.19. In the year 2011, what is the difference between the Gross intake ratio(%) of High income: OECD and Gross intake ratio(%) of China?
Offer a very short reply. -9.13. In the year 2011, what is the difference between the Gross intake ratio(%) in High income: OECD and Gross intake ratio(%) in Czech Republic?
Your answer should be compact. 2.24. In the year 2011, what is the difference between the Gross intake ratio(%) of High income: OECD and Gross intake ratio(%) of Israel?
Ensure brevity in your answer.  -1.51. In the year 2011, what is the difference between the Gross intake ratio(%) in China and Gross intake ratio(%) in Czech Republic?
Make the answer very short. 11.37. In the year 2011, what is the difference between the Gross intake ratio(%) of China and Gross intake ratio(%) of Israel?
Your answer should be compact. 7.62. In the year 2011, what is the difference between the Gross intake ratio(%) of Czech Republic and Gross intake ratio(%) of Israel?
Your answer should be compact. -3.75. What is the ratio of the Gross intake ratio(%) in High income: OECD in 2002 to that in 2003?
Offer a terse response. 1. What is the ratio of the Gross intake ratio(%) in China in 2002 to that in 2003?
Your answer should be compact. 0.95. What is the ratio of the Gross intake ratio(%) in Czech Republic in 2002 to that in 2003?
Ensure brevity in your answer.  0.98. What is the ratio of the Gross intake ratio(%) of Israel in 2002 to that in 2003?
Offer a very short reply. 1.04. What is the ratio of the Gross intake ratio(%) in High income: OECD in 2002 to that in 2006?
Provide a succinct answer. 0.97. What is the ratio of the Gross intake ratio(%) of China in 2002 to that in 2006?
Give a very brief answer. 0.96. What is the ratio of the Gross intake ratio(%) of Czech Republic in 2002 to that in 2006?
Your answer should be compact. 0.81. What is the ratio of the Gross intake ratio(%) in Israel in 2002 to that in 2006?
Provide a short and direct response. 1.06. What is the ratio of the Gross intake ratio(%) in High income: OECD in 2002 to that in 2007?
Ensure brevity in your answer.  0.95. What is the ratio of the Gross intake ratio(%) of China in 2002 to that in 2007?
Make the answer very short. 0.89. What is the ratio of the Gross intake ratio(%) in Czech Republic in 2002 to that in 2007?
Make the answer very short. 0.81. What is the ratio of the Gross intake ratio(%) of High income: OECD in 2002 to that in 2008?
Ensure brevity in your answer.  0.95. What is the ratio of the Gross intake ratio(%) in China in 2002 to that in 2008?
Your response must be concise. 0.87. What is the ratio of the Gross intake ratio(%) of Czech Republic in 2002 to that in 2008?
Give a very brief answer. 0.83. What is the ratio of the Gross intake ratio(%) in Israel in 2002 to that in 2008?
Offer a terse response. 1.05. What is the ratio of the Gross intake ratio(%) in High income: OECD in 2002 to that in 2009?
Your response must be concise. 0.98. What is the ratio of the Gross intake ratio(%) in China in 2002 to that in 2009?
Offer a very short reply. 0.88. What is the ratio of the Gross intake ratio(%) in Czech Republic in 2002 to that in 2009?
Provide a succinct answer. 0.85. What is the ratio of the Gross intake ratio(%) in Israel in 2002 to that in 2009?
Your answer should be very brief. 1.04. What is the ratio of the Gross intake ratio(%) of High income: OECD in 2002 to that in 2010?
Make the answer very short. 1. What is the ratio of the Gross intake ratio(%) of China in 2002 to that in 2010?
Keep it short and to the point. 0.91. What is the ratio of the Gross intake ratio(%) of Czech Republic in 2002 to that in 2010?
Your answer should be very brief. 0.89. What is the ratio of the Gross intake ratio(%) of Israel in 2002 to that in 2010?
Offer a very short reply. 0.96. What is the ratio of the Gross intake ratio(%) of High income: OECD in 2002 to that in 2011?
Keep it short and to the point. 0.99. What is the ratio of the Gross intake ratio(%) in China in 2002 to that in 2011?
Provide a short and direct response. 0.89. What is the ratio of the Gross intake ratio(%) of Czech Republic in 2002 to that in 2011?
Your answer should be very brief. 0.92. What is the ratio of the Gross intake ratio(%) of Israel in 2002 to that in 2011?
Keep it short and to the point. 1.02. What is the ratio of the Gross intake ratio(%) of High income: OECD in 2003 to that in 2006?
Offer a terse response. 0.97. What is the ratio of the Gross intake ratio(%) of China in 2003 to that in 2006?
Provide a succinct answer. 1.01. What is the ratio of the Gross intake ratio(%) in Czech Republic in 2003 to that in 2006?
Your answer should be compact. 0.83. What is the ratio of the Gross intake ratio(%) of Israel in 2003 to that in 2006?
Provide a short and direct response. 1.01. What is the ratio of the Gross intake ratio(%) of High income: OECD in 2003 to that in 2007?
Offer a terse response. 0.95. What is the ratio of the Gross intake ratio(%) of China in 2003 to that in 2007?
Provide a short and direct response. 0.94. What is the ratio of the Gross intake ratio(%) of Czech Republic in 2003 to that in 2007?
Your response must be concise. 0.82. What is the ratio of the Gross intake ratio(%) of Israel in 2003 to that in 2007?
Provide a succinct answer. 0.96. What is the ratio of the Gross intake ratio(%) in High income: OECD in 2003 to that in 2008?
Give a very brief answer. 0.95. What is the ratio of the Gross intake ratio(%) in China in 2003 to that in 2008?
Your answer should be very brief. 0.92. What is the ratio of the Gross intake ratio(%) of Czech Republic in 2003 to that in 2008?
Your response must be concise. 0.84. What is the ratio of the Gross intake ratio(%) in High income: OECD in 2003 to that in 2009?
Give a very brief answer. 0.98. What is the ratio of the Gross intake ratio(%) in China in 2003 to that in 2009?
Ensure brevity in your answer.  0.93. What is the ratio of the Gross intake ratio(%) in Czech Republic in 2003 to that in 2009?
Offer a very short reply. 0.86. What is the ratio of the Gross intake ratio(%) of China in 2003 to that in 2010?
Offer a terse response. 0.96. What is the ratio of the Gross intake ratio(%) in Czech Republic in 2003 to that in 2010?
Make the answer very short. 0.91. What is the ratio of the Gross intake ratio(%) in Israel in 2003 to that in 2010?
Provide a short and direct response. 0.92. What is the ratio of the Gross intake ratio(%) of High income: OECD in 2003 to that in 2011?
Give a very brief answer. 0.99. What is the ratio of the Gross intake ratio(%) in China in 2003 to that in 2011?
Give a very brief answer. 0.94. What is the ratio of the Gross intake ratio(%) of Israel in 2003 to that in 2011?
Your answer should be very brief. 0.98. What is the ratio of the Gross intake ratio(%) in High income: OECD in 2006 to that in 2007?
Your answer should be compact. 0.98. What is the ratio of the Gross intake ratio(%) in China in 2006 to that in 2007?
Provide a succinct answer. 0.93. What is the ratio of the Gross intake ratio(%) of Czech Republic in 2006 to that in 2007?
Provide a short and direct response. 0.99. What is the ratio of the Gross intake ratio(%) of High income: OECD in 2006 to that in 2008?
Provide a short and direct response. 0.98. What is the ratio of the Gross intake ratio(%) of China in 2006 to that in 2008?
Provide a short and direct response. 0.91. What is the ratio of the Gross intake ratio(%) in Czech Republic in 2006 to that in 2008?
Ensure brevity in your answer.  1.02. What is the ratio of the Gross intake ratio(%) of Israel in 2006 to that in 2008?
Offer a very short reply. 0.99. What is the ratio of the Gross intake ratio(%) in China in 2006 to that in 2009?
Your answer should be very brief. 0.92. What is the ratio of the Gross intake ratio(%) in Czech Republic in 2006 to that in 2009?
Your answer should be very brief. 1.05. What is the ratio of the Gross intake ratio(%) in Israel in 2006 to that in 2009?
Your answer should be very brief. 0.98. What is the ratio of the Gross intake ratio(%) in High income: OECD in 2006 to that in 2010?
Offer a very short reply. 1.02. What is the ratio of the Gross intake ratio(%) of China in 2006 to that in 2010?
Your answer should be compact. 0.94. What is the ratio of the Gross intake ratio(%) of Czech Republic in 2006 to that in 2010?
Keep it short and to the point. 1.1. What is the ratio of the Gross intake ratio(%) of Israel in 2006 to that in 2010?
Offer a very short reply. 0.91. What is the ratio of the Gross intake ratio(%) in High income: OECD in 2006 to that in 2011?
Offer a terse response. 1.02. What is the ratio of the Gross intake ratio(%) in China in 2006 to that in 2011?
Offer a terse response. 0.93. What is the ratio of the Gross intake ratio(%) in Czech Republic in 2006 to that in 2011?
Offer a very short reply. 1.13. What is the ratio of the Gross intake ratio(%) of Israel in 2006 to that in 2011?
Offer a terse response. 0.97. What is the ratio of the Gross intake ratio(%) in China in 2007 to that in 2008?
Offer a very short reply. 0.98. What is the ratio of the Gross intake ratio(%) in Israel in 2007 to that in 2008?
Provide a succinct answer. 1.05. What is the ratio of the Gross intake ratio(%) in High income: OECD in 2007 to that in 2009?
Give a very brief answer. 1.03. What is the ratio of the Gross intake ratio(%) of China in 2007 to that in 2009?
Keep it short and to the point. 0.99. What is the ratio of the Gross intake ratio(%) of Czech Republic in 2007 to that in 2009?
Provide a short and direct response. 1.05. What is the ratio of the Gross intake ratio(%) in Israel in 2007 to that in 2009?
Offer a terse response. 1.03. What is the ratio of the Gross intake ratio(%) in High income: OECD in 2007 to that in 2010?
Your answer should be very brief. 1.04. What is the ratio of the Gross intake ratio(%) of China in 2007 to that in 2010?
Give a very brief answer. 1.02. What is the ratio of the Gross intake ratio(%) of Czech Republic in 2007 to that in 2010?
Provide a short and direct response. 1.11. What is the ratio of the Gross intake ratio(%) in Israel in 2007 to that in 2010?
Provide a short and direct response. 0.96. What is the ratio of the Gross intake ratio(%) of High income: OECD in 2007 to that in 2011?
Offer a terse response. 1.04. What is the ratio of the Gross intake ratio(%) in Czech Republic in 2007 to that in 2011?
Provide a succinct answer. 1.14. What is the ratio of the Gross intake ratio(%) of Israel in 2007 to that in 2011?
Provide a short and direct response. 1.02. What is the ratio of the Gross intake ratio(%) in High income: OECD in 2008 to that in 2009?
Your answer should be very brief. 1.03. What is the ratio of the Gross intake ratio(%) of China in 2008 to that in 2009?
Offer a terse response. 1.01. What is the ratio of the Gross intake ratio(%) in Czech Republic in 2008 to that in 2009?
Offer a very short reply. 1.03. What is the ratio of the Gross intake ratio(%) in Israel in 2008 to that in 2009?
Offer a very short reply. 0.99. What is the ratio of the Gross intake ratio(%) of High income: OECD in 2008 to that in 2010?
Give a very brief answer. 1.04. What is the ratio of the Gross intake ratio(%) of China in 2008 to that in 2010?
Your response must be concise. 1.04. What is the ratio of the Gross intake ratio(%) of Czech Republic in 2008 to that in 2010?
Offer a terse response. 1.08. What is the ratio of the Gross intake ratio(%) of Israel in 2008 to that in 2010?
Your response must be concise. 0.92. What is the ratio of the Gross intake ratio(%) of High income: OECD in 2008 to that in 2011?
Provide a succinct answer. 1.04. What is the ratio of the Gross intake ratio(%) of Czech Republic in 2008 to that in 2011?
Provide a short and direct response. 1.11. What is the ratio of the Gross intake ratio(%) of Israel in 2008 to that in 2011?
Provide a succinct answer. 0.98. What is the ratio of the Gross intake ratio(%) of High income: OECD in 2009 to that in 2010?
Provide a succinct answer. 1.02. What is the ratio of the Gross intake ratio(%) in China in 2009 to that in 2010?
Provide a short and direct response. 1.03. What is the ratio of the Gross intake ratio(%) in Czech Republic in 2009 to that in 2010?
Give a very brief answer. 1.05. What is the ratio of the Gross intake ratio(%) of High income: OECD in 2009 to that in 2011?
Provide a succinct answer. 1.01. What is the ratio of the Gross intake ratio(%) in China in 2009 to that in 2011?
Make the answer very short. 1.01. What is the ratio of the Gross intake ratio(%) in Czech Republic in 2009 to that in 2011?
Offer a terse response. 1.08. What is the ratio of the Gross intake ratio(%) in Israel in 2009 to that in 2011?
Provide a succinct answer. 0.99. What is the ratio of the Gross intake ratio(%) in China in 2010 to that in 2011?
Provide a succinct answer. 0.98. What is the ratio of the Gross intake ratio(%) in Czech Republic in 2010 to that in 2011?
Make the answer very short. 1.03. What is the ratio of the Gross intake ratio(%) in Israel in 2010 to that in 2011?
Give a very brief answer. 1.06. What is the difference between the highest and the second highest Gross intake ratio(%) of High income: OECD?
Keep it short and to the point. 0.05. What is the difference between the highest and the second highest Gross intake ratio(%) in China?
Provide a succinct answer. 1.57. What is the difference between the highest and the second highest Gross intake ratio(%) in Czech Republic?
Your answer should be very brief. 0.74. What is the difference between the highest and the second highest Gross intake ratio(%) of Israel?
Offer a very short reply. 4.02. What is the difference between the highest and the lowest Gross intake ratio(%) of High income: OECD?
Make the answer very short. 4.93. What is the difference between the highest and the lowest Gross intake ratio(%) in China?
Make the answer very short. 14.54. What is the difference between the highest and the lowest Gross intake ratio(%) of Czech Republic?
Offer a very short reply. 21.82. What is the difference between the highest and the lowest Gross intake ratio(%) in Israel?
Make the answer very short. 9.73. 